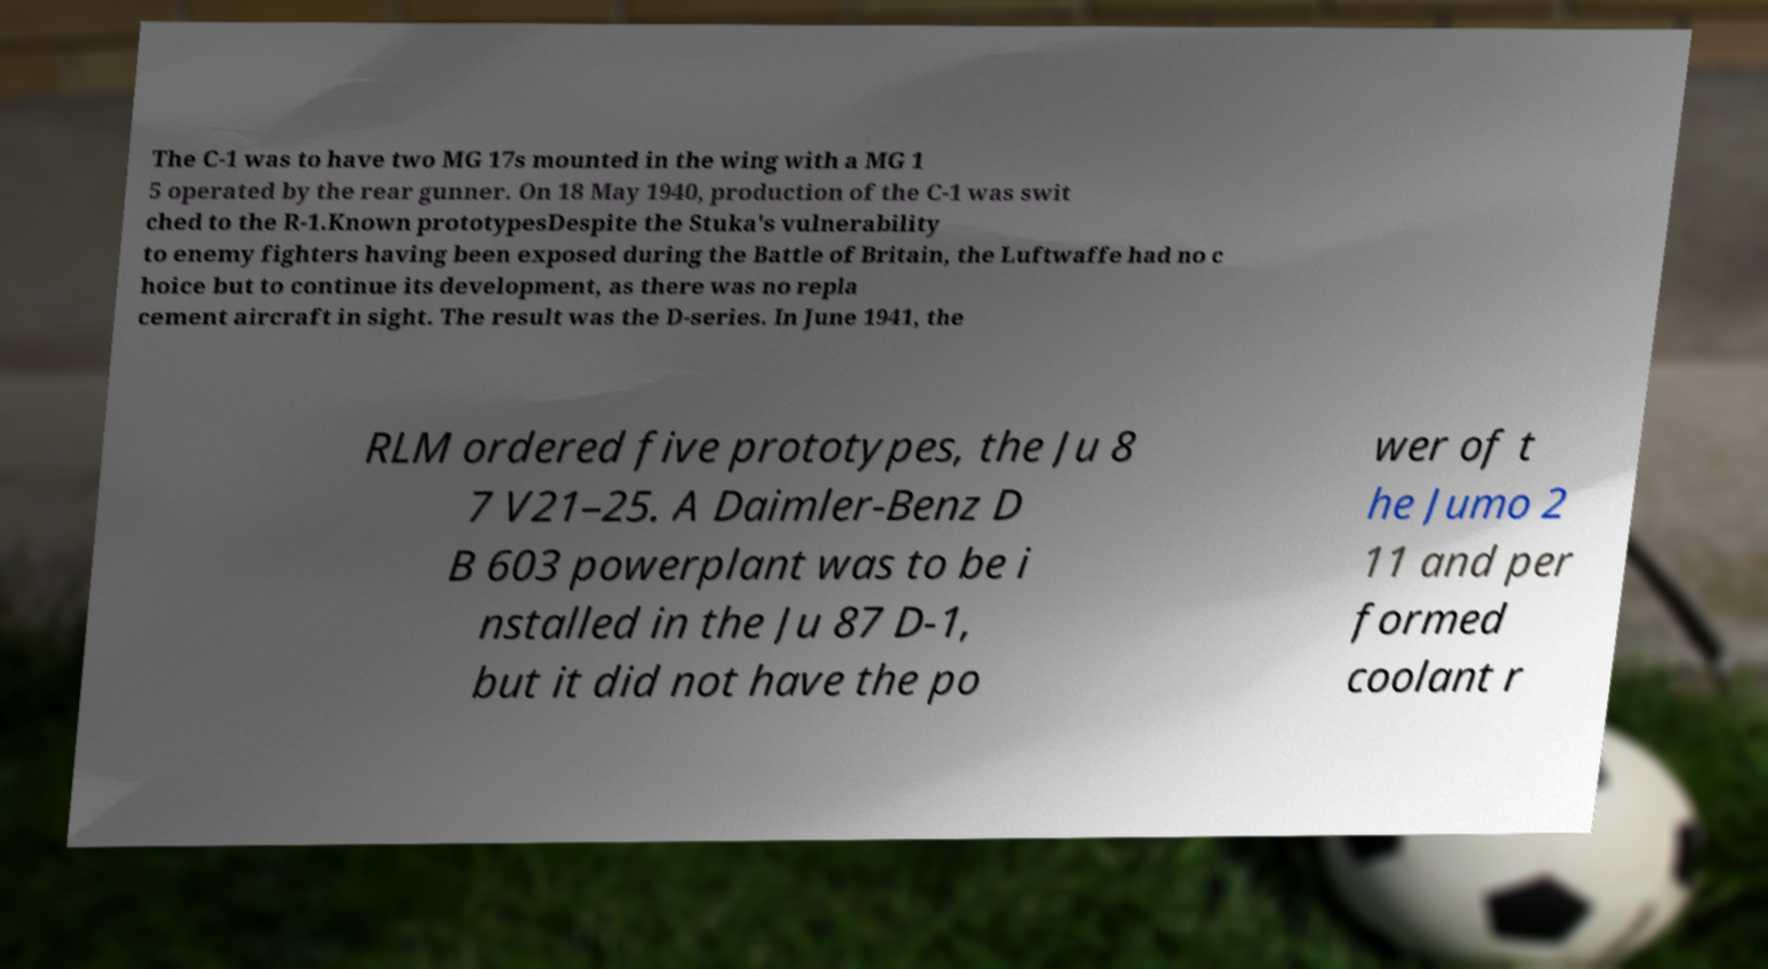Could you assist in decoding the text presented in this image and type it out clearly? The C-1 was to have two MG 17s mounted in the wing with a MG 1 5 operated by the rear gunner. On 18 May 1940, production of the C-1 was swit ched to the R-1.Known prototypesDespite the Stuka's vulnerability to enemy fighters having been exposed during the Battle of Britain, the Luftwaffe had no c hoice but to continue its development, as there was no repla cement aircraft in sight. The result was the D-series. In June 1941, the RLM ordered five prototypes, the Ju 8 7 V21–25. A Daimler-Benz D B 603 powerplant was to be i nstalled in the Ju 87 D-1, but it did not have the po wer of t he Jumo 2 11 and per formed coolant r 